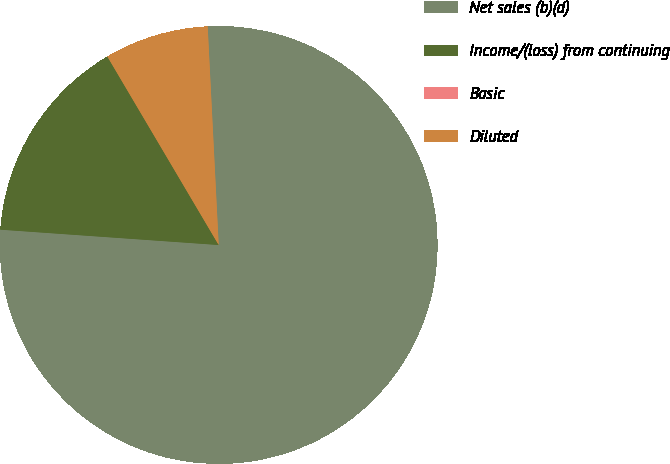<chart> <loc_0><loc_0><loc_500><loc_500><pie_chart><fcel>Net sales (b)(d)<fcel>Income/(loss) from continuing<fcel>Basic<fcel>Diluted<nl><fcel>76.92%<fcel>15.39%<fcel>0.0%<fcel>7.69%<nl></chart> 